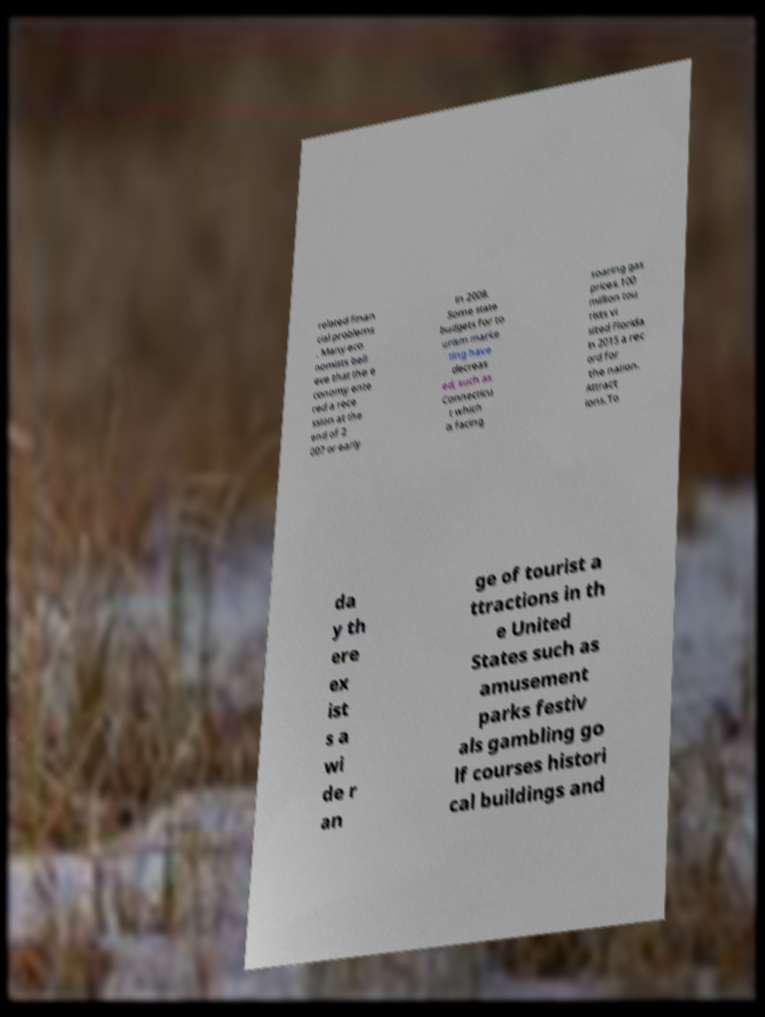Please identify and transcribe the text found in this image. related finan cial problems . Many eco nomists beli eve that the e conomy ente red a rece ssion at the end of 2 007 or early in 2008. Some state budgets for to urism marke ting have decreas ed, such as Connecticu t which is facing soaring gas prices.100 million tou rists vi sited Florida in 2015 a rec ord for the nation. Attract ions.To da y th ere ex ist s a wi de r an ge of tourist a ttractions in th e United States such as amusement parks festiv als gambling go lf courses histori cal buildings and 